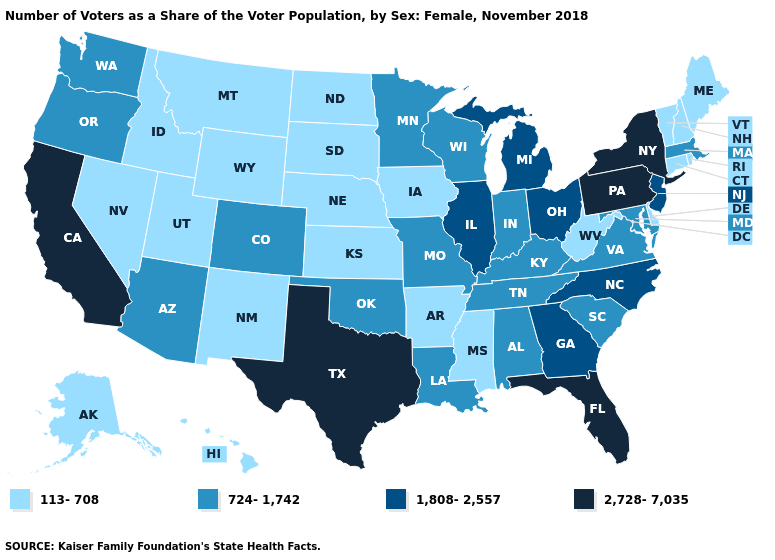Among the states that border Illinois , does Iowa have the highest value?
Write a very short answer. No. What is the value of Indiana?
Answer briefly. 724-1,742. Name the states that have a value in the range 113-708?
Concise answer only. Alaska, Arkansas, Connecticut, Delaware, Hawaii, Idaho, Iowa, Kansas, Maine, Mississippi, Montana, Nebraska, Nevada, New Hampshire, New Mexico, North Dakota, Rhode Island, South Dakota, Utah, Vermont, West Virginia, Wyoming. Which states hav the highest value in the South?
Be succinct. Florida, Texas. Name the states that have a value in the range 724-1,742?
Short answer required. Alabama, Arizona, Colorado, Indiana, Kentucky, Louisiana, Maryland, Massachusetts, Minnesota, Missouri, Oklahoma, Oregon, South Carolina, Tennessee, Virginia, Washington, Wisconsin. What is the value of Indiana?
Concise answer only. 724-1,742. What is the value of North Carolina?
Be succinct. 1,808-2,557. Does Pennsylvania have the highest value in the USA?
Give a very brief answer. Yes. What is the lowest value in states that border New Jersey?
Keep it brief. 113-708. Name the states that have a value in the range 113-708?
Concise answer only. Alaska, Arkansas, Connecticut, Delaware, Hawaii, Idaho, Iowa, Kansas, Maine, Mississippi, Montana, Nebraska, Nevada, New Hampshire, New Mexico, North Dakota, Rhode Island, South Dakota, Utah, Vermont, West Virginia, Wyoming. Which states have the highest value in the USA?
Write a very short answer. California, Florida, New York, Pennsylvania, Texas. Does Oklahoma have the same value as Colorado?
Concise answer only. Yes. Does Montana have the same value as Alaska?
Give a very brief answer. Yes. What is the highest value in the South ?
Quick response, please. 2,728-7,035. Among the states that border South Carolina , which have the lowest value?
Give a very brief answer. Georgia, North Carolina. 